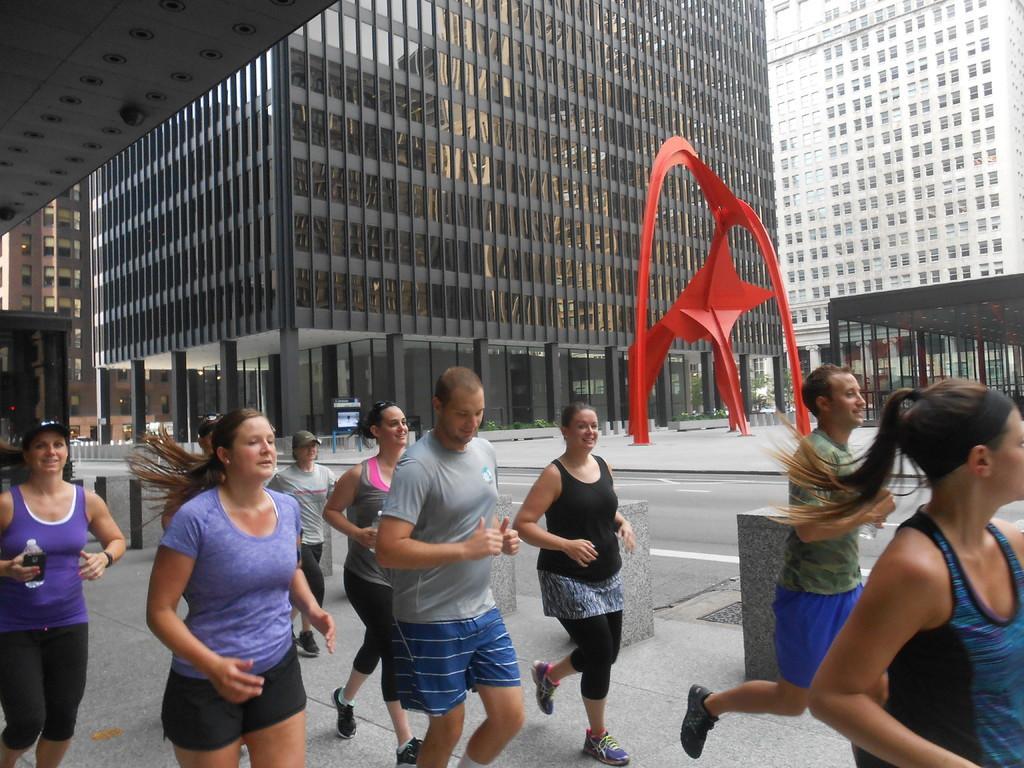Could you give a brief overview of what you see in this image? In this image I can see some people. I can see the road. In the background, I can see the buildings with the windows. 